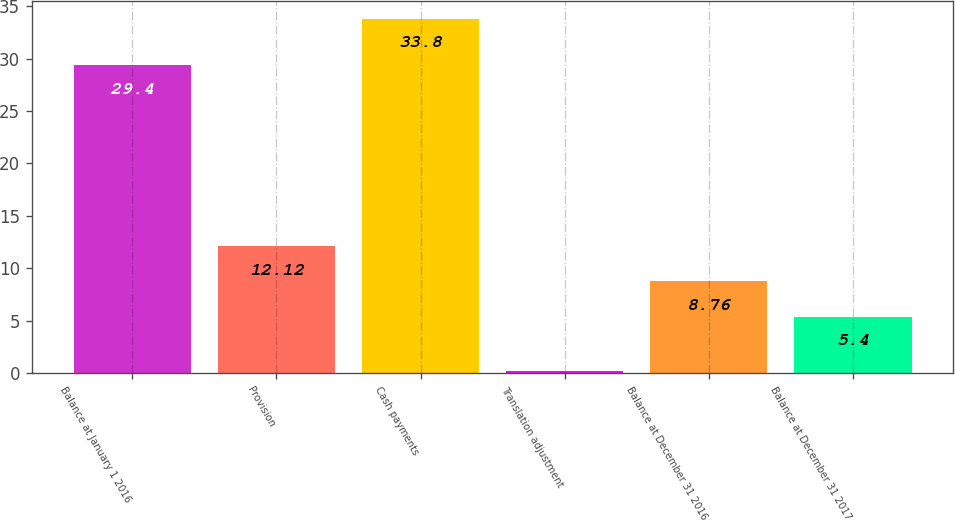Convert chart to OTSL. <chart><loc_0><loc_0><loc_500><loc_500><bar_chart><fcel>Balance at January 1 2016<fcel>Provision<fcel>Cash payments<fcel>Translation adjustment<fcel>Balance at December 31 2016<fcel>Balance at December 31 2017<nl><fcel>29.4<fcel>12.12<fcel>33.8<fcel>0.2<fcel>8.76<fcel>5.4<nl></chart> 